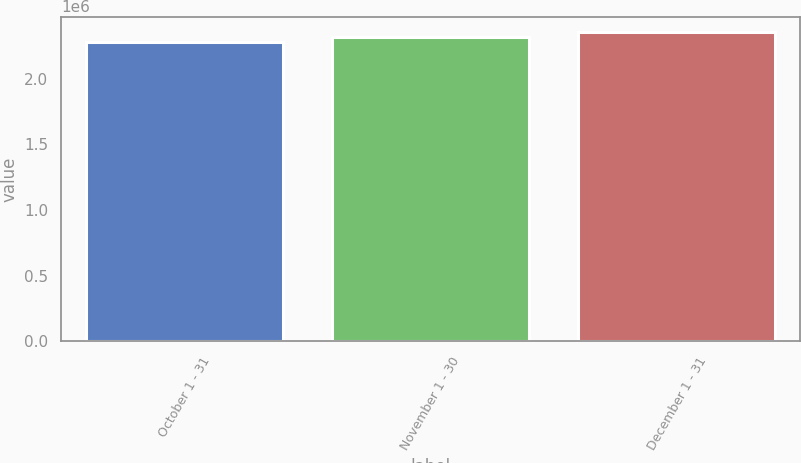Convert chart. <chart><loc_0><loc_0><loc_500><loc_500><bar_chart><fcel>October 1 - 31<fcel>November 1 - 30<fcel>December 1 - 31<nl><fcel>2.27645e+06<fcel>2.31486e+06<fcel>2.35307e+06<nl></chart> 